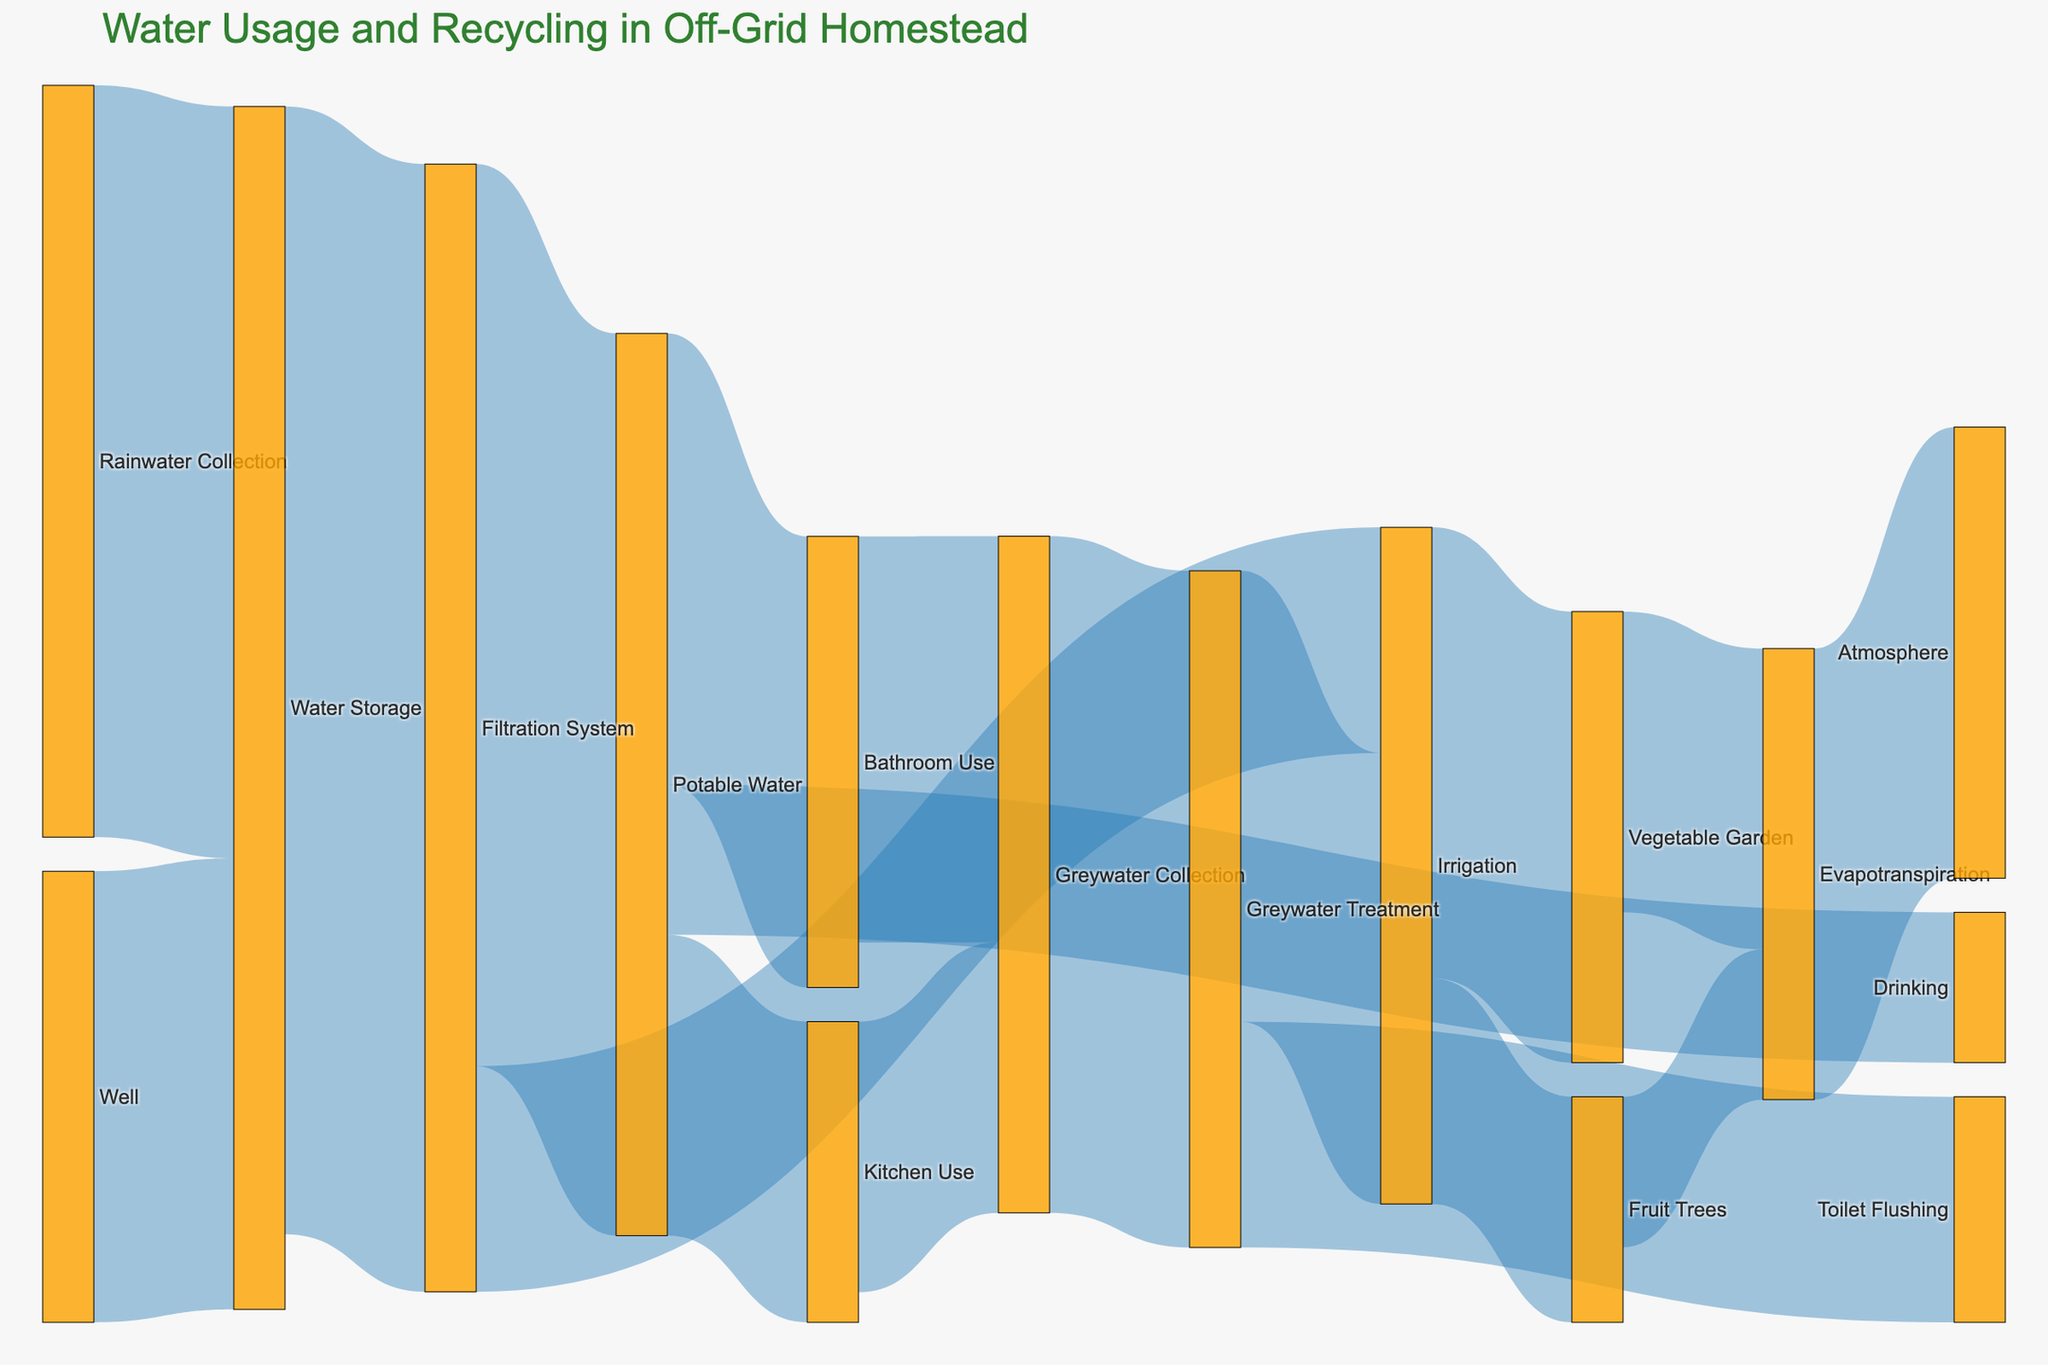What is the total amount of water collected from rainwater and well sources? Add the values together: Rainwater Collection (5000) + Well (3000) = 8000
Answer: 8000 Which usage consumes the most potable water? Look at the branches from 'Potable Water' and compare their values: Kitchen Use (2000), Bathroom Use (3000), Drinking (1000). Bathroom Use is the highest.
Answer: Bathroom Use What is the primary destination of greywater after collection? Look at the branches from 'Greywater Collection' and identify the largest value: Greywater Treatment (4500)
Answer: Greywater Treatment How much water is used for irrigation purposes in total? Sum all the irrigation values from 'Filtration System' and 'Greywater Treatment': Filtration System to Irrigation (1500) + Greywater Treatment to Irrigation (3000) = 4500
Answer: 4500 What is the end point of water used in irrigation? Check the destinations from 'Irrigation': Vegetable Garden (3000), Fruit Trees (1500). Both end at Evapotranspiration, finally leading to the Atmosphere (3000)
Answer: Atmosphere How much water is treated in the Filtration System? Sum the values incoming to 'Filtration System': Water Storage to Filtration System (7500)
Answer: 7500 Compare the volume of water used for Toilet Flushing and Drinking. Which one is higher? Check the values for both purposes: Toilet Flushing (1500), Drinking (1000). Toilet Flushing is higher.
Answer: Toilet Flushing What proportion of kitchen-used water is collected as greywater? Divide the greywater collected from Kitchen Use by the Kitchen Use value itself: 1800/2000 = 0.9 or 90%
Answer: 90% What happens to the water used in bathroom if none of it is recycled? It flows into Greywater Collection (2700) and eventually gets treated or utilized for irrigation and toilet flushing. Based on the diagram flow.
Answer: It flows into Greywater Collection Calculate the percentage of rainwater used out of the total collected water sources (Rainwater and Well). Rainwater Collection (5000) divided by Total Collection (5000 + 3000) = 5000/8000 = 0.625 or 62.5%
Answer: 62.5% 